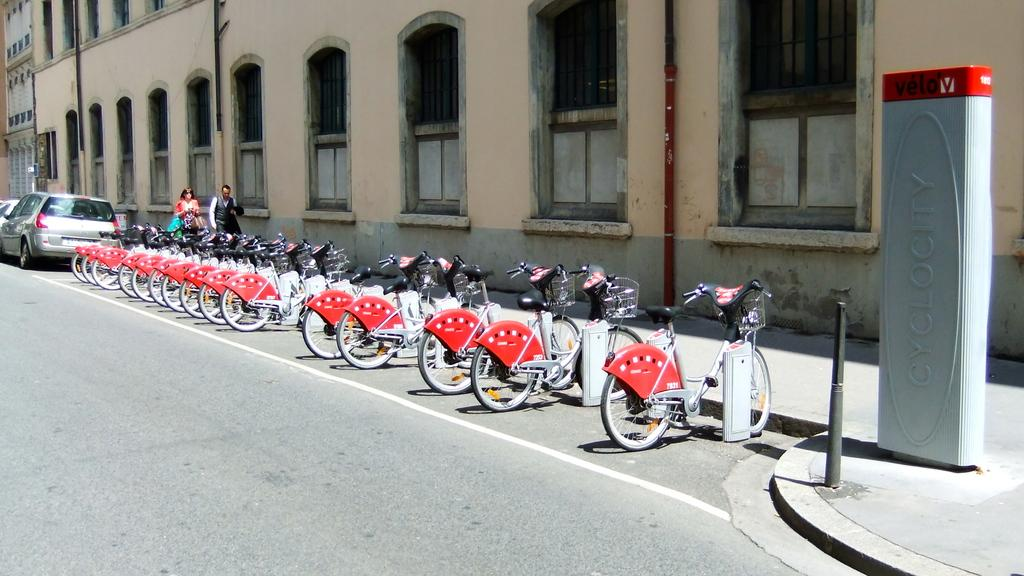What type of vehicles are on the road in the image? There are bicycles and a car on the road in the image. How many people are visible in the image? There are two people in the image. What can be seen in the background of the image? There is a building in the background of the image. What type of scent can be detected in the image? There is no mention of a scent in the image, so it cannot be determined from the image. What type of acoustics can be heard in the image? There is no mention of sound or acoustics in the image, so it cannot be determined from the image. 